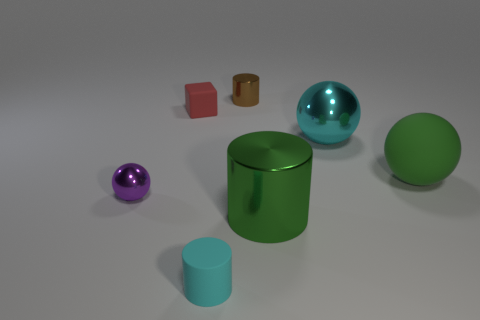Subtract all metallic spheres. How many spheres are left? 1 Add 2 green matte balls. How many objects exist? 9 Subtract all cubes. How many objects are left? 6 Subtract all tiny purple metal objects. Subtract all small metallic objects. How many objects are left? 4 Add 7 large green balls. How many large green balls are left? 8 Add 5 metallic objects. How many metallic objects exist? 9 Subtract 1 cyan cylinders. How many objects are left? 6 